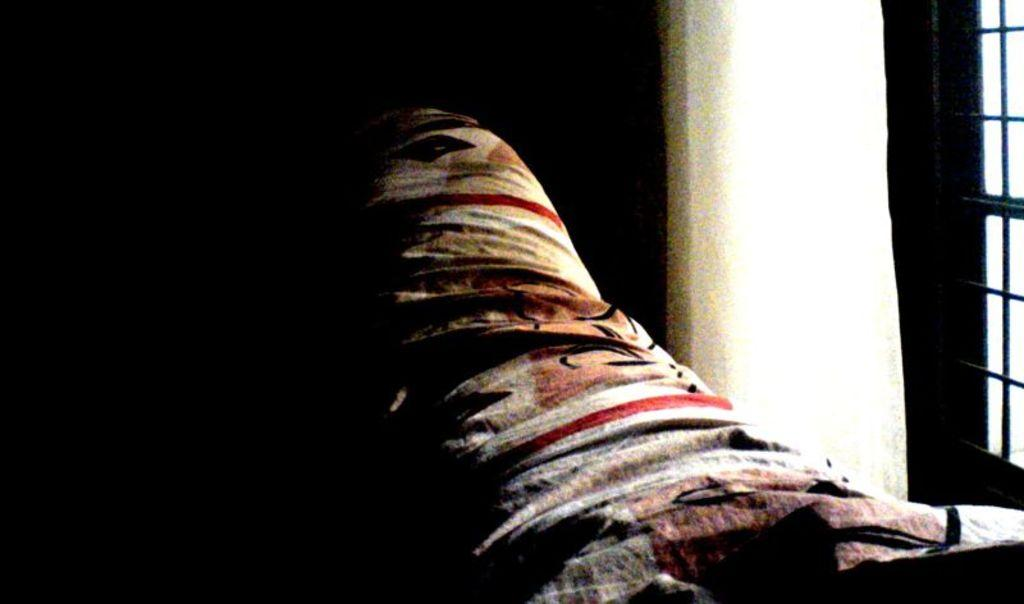What is the main object in the center of the image? There is a cloth in the center of the image. What can be seen on the right side of the image? There is a window on the right side of the image. What type of teaching is happening in the image? There is no teaching happening in the image; it only features a cloth and a window. How many chairs are visible in the image? There are no chairs present in the image. 